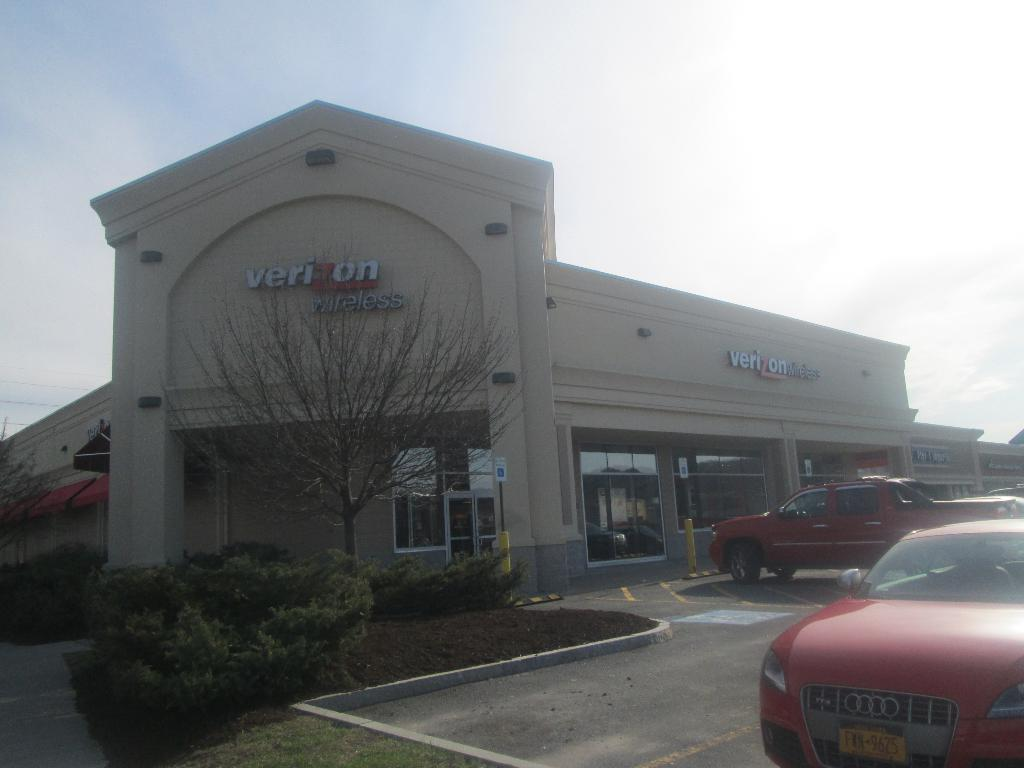What types of vehicles are in the image? There are vehicles in the image, but the specific types are not mentioned. What can be seen on the building in the image? The building in the image has windows. What is located in front of the building? There is a tree in front of the building. What type of vegetation is present in the image besides the tree? There are bushes in the image. What is visible in the background of the image? The sky is visible in the background of the image. What religious verse is written on the tree in the image? There is no mention of any religious verse or text on the tree in the image. Is there a bear visible in the image? No, there is no bear present in the image. 